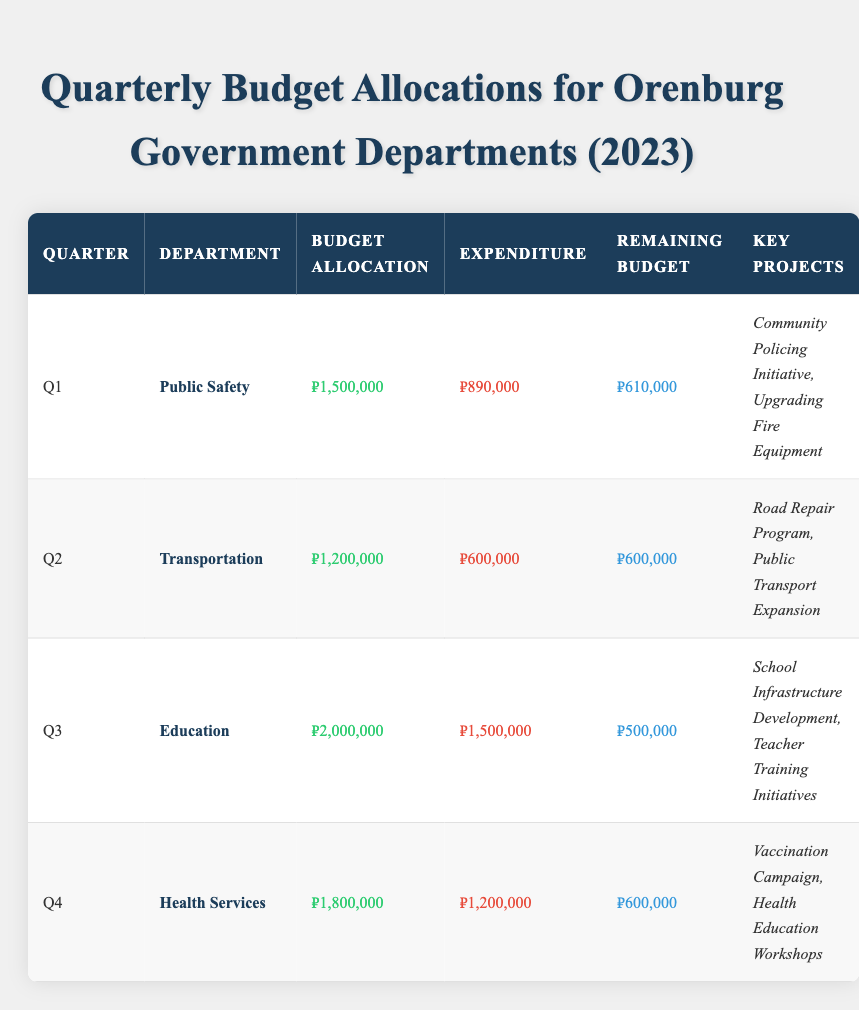What was the budget allocation for the Public Safety department in Q1? The table indicates that the budget allocation for the Public Safety department in Q1 is listed under the Budget Allocation column for Q1. The value is 1,500,000.
Answer: ₽1,500,000 How much expenditure did the Transportation department have in Q2? By looking at the Q2 row, the Expenditure column shows that the Transportation department had an expenditure of 600,000.
Answer: ₽600,000 What is the remaining budget for the Health Services department in Q4? The table shows that for Q4, the Health Services department's Remaining Budget is listed as 600,000.
Answer: ₽600,000 Which department had the highest budget allocation in the third quarter? Referring to the Q3 row, the Education department had a budget allocation of 2,000,000, which is greater than allocations for other departments in their respective quarters.
Answer: Education What was the total budget allocated across all departments for the year? The total budget can be calculated by summing the allocations for all quarters: 1,500,000 + 1,200,000 + 2,000,000 + 1,800,000 = 6,500,000.
Answer: ₽6,500,000 Did any department fully utilize its allocated budget in any quarter? Looking at the expenditures and remaining budgets, all departments have remaining budgets after Q1, Q2, Q3, and Q4; thus, none fully utilized their allocations.
Answer: No What is the average remaining budget for all departments after each quarter? The remaining budgets are 610,000 (Q1), 600,000 (Q2), 500,000 (Q3), and 600,000 (Q4). The sum is 2,310,000, and dividing by 4 gives an average of 577,500.
Answer: ₽577,500 What was the total expenditure for the Education department in 2023? The Education department’s expenditure is only noted for Q3 as 1,500,000, thus that is the total expenditure for the department for the year.
Answer: ₽1,500,000 Which quarter had the highest budget allocation and what was the amount? The Q3 quarter had the highest budget allocation for the Education department, which was 2,000,000.
Answer: ₽2,000,000 Is the expenditure of the Health Services department in Q4 higher than its remaining budget? The expenditure for Health Services in Q4 is 1,200,000, while the remaining budget is 600,000. Since 1,200,000 > 600,000, it is indeed higher.
Answer: Yes 